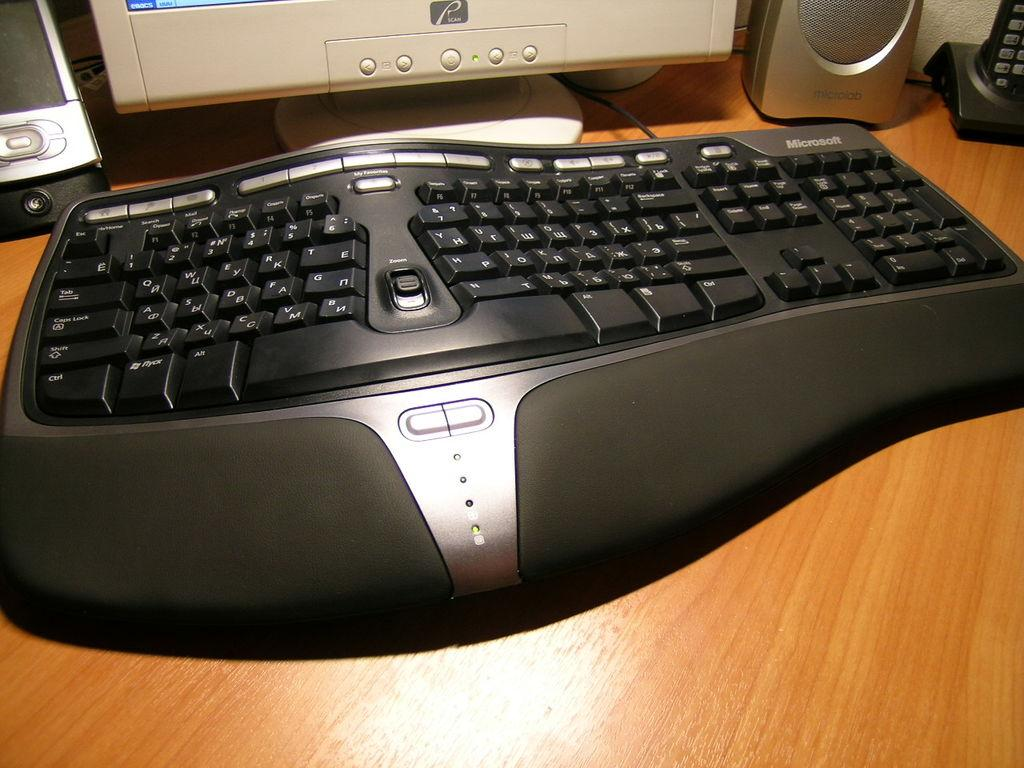<image>
Share a concise interpretation of the image provided. Large Microsoft keyboard in front of a white monitor. 